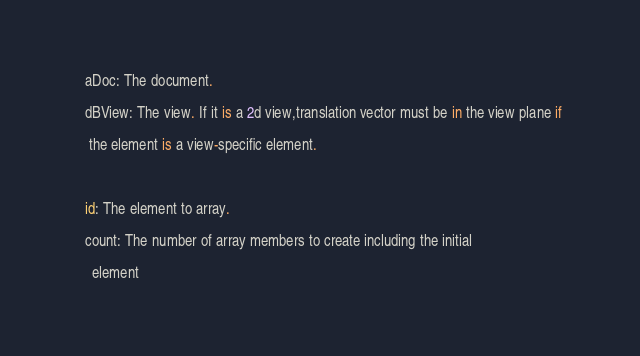Convert code to text. <code><loc_0><loc_0><loc_500><loc_500><_Python_>
   aDoc: The document.

   dBView: The view. If it is a 2d view,translation vector must be in the view plane if 

    the element is a view-specific element.

  

   id: The element to array.

   count: The number of array members to create including the initial

     element 
</code> 